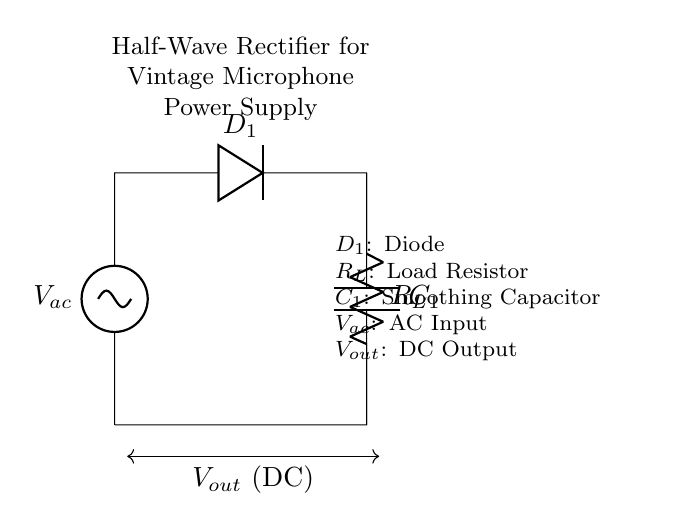What is the AC input voltage labeled in the circuit? The circuit shows the AC input voltage labeled as Vac, which does not have a specific numerical value in the diagram but is expected to be an alternating voltage source.
Answer: Vac What component is used to convert AC to DC? The diode labeled as D1 is the component that allows current to flow in only one direction, thus converting AC to DC.
Answer: D1 What type of circuit is depicted in the diagram? The diagram represents a half-wave rectifier circuit, which allows only one half of the AC waveform to pass through, effectively rectifying the voltage.
Answer: Half-wave rectifier What is the purpose of the capacitor labeled C1? The capacitor C1 is used to smooth the rectified DC output by storing charge and releasing it, reducing voltage ripple.
Answer: Smoothing What is the role of the load resistor labeled R_L? The load resistor R_L represents the load that consumes the rectified and smoothed DC voltage, allowing current flow through the circuit.
Answer: Load resistor How many diodes are present in the circuit? The circuit contains a single diode, D1, which is crucial for rectification in this half-wave rectifier setup.
Answer: One What is the connection type for the output voltage labeled V_out? The output voltage V_out is connected across the load resistor R_L and the capacitor C1, providing the DC output from the rectifier circuit.
Answer: Across R_L and C1 